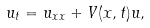<formula> <loc_0><loc_0><loc_500><loc_500>u _ { t } = u _ { x x } + V ( x , t ) u ,</formula> 